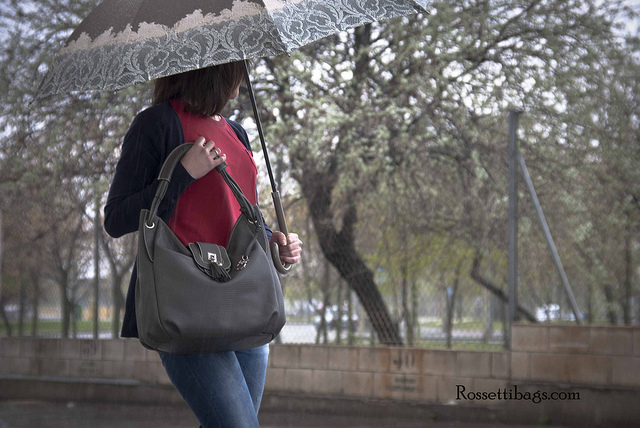Read and extract the text from this image. Rossettibags.com 40 